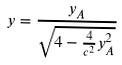Convert formula to latex. <formula><loc_0><loc_0><loc_500><loc_500>y = \frac { y _ { A } } { \sqrt { 4 - \frac { 4 } { c ^ { 2 } } y _ { A } ^ { 2 } } }</formula> 